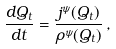Convert formula to latex. <formula><loc_0><loc_0><loc_500><loc_500>\frac { d Q _ { t } } { d t } = \frac { j ^ { \psi } ( Q _ { t } ) } { \rho ^ { \psi } ( Q _ { t } ) } \, ,</formula> 